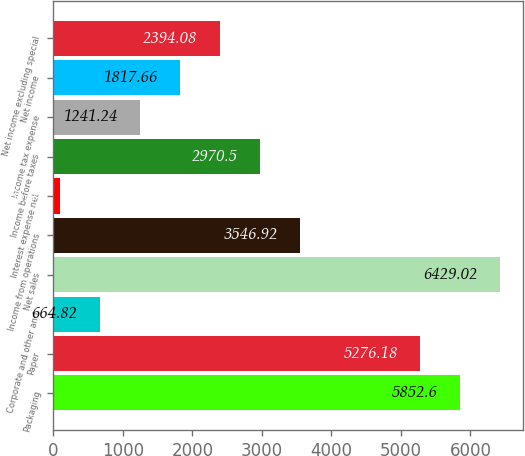<chart> <loc_0><loc_0><loc_500><loc_500><bar_chart><fcel>Packaging<fcel>Paper<fcel>Corporate and other and<fcel>Net sales<fcel>Income from operations<fcel>Interest expense net<fcel>Income before taxes<fcel>Income tax expense<fcel>Net income<fcel>Net income excluding special<nl><fcel>5852.6<fcel>5276.18<fcel>664.82<fcel>6429.02<fcel>3546.92<fcel>88.4<fcel>2970.5<fcel>1241.24<fcel>1817.66<fcel>2394.08<nl></chart> 